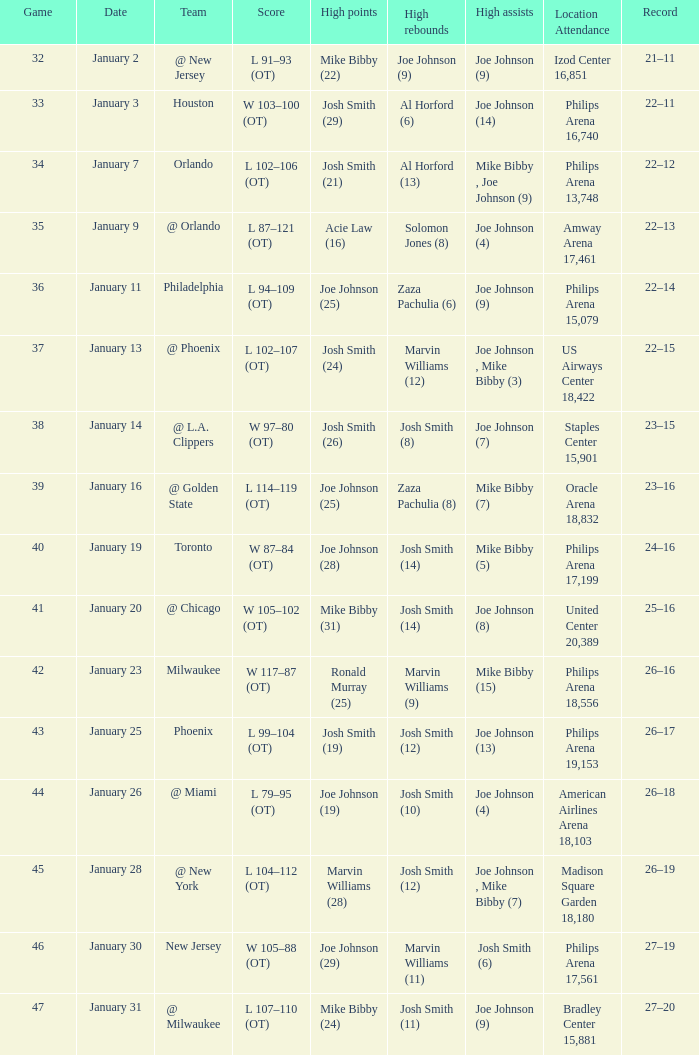What was the standing following the 37th game? 22–15. I'm looking to parse the entire table for insights. Could you assist me with that? {'header': ['Game', 'Date', 'Team', 'Score', 'High points', 'High rebounds', 'High assists', 'Location Attendance', 'Record'], 'rows': [['32', 'January 2', '@ New Jersey', 'L 91–93 (OT)', 'Mike Bibby (22)', 'Joe Johnson (9)', 'Joe Johnson (9)', 'Izod Center 16,851', '21–11'], ['33', 'January 3', 'Houston', 'W 103–100 (OT)', 'Josh Smith (29)', 'Al Horford (6)', 'Joe Johnson (14)', 'Philips Arena 16,740', '22–11'], ['34', 'January 7', 'Orlando', 'L 102–106 (OT)', 'Josh Smith (21)', 'Al Horford (13)', 'Mike Bibby , Joe Johnson (9)', 'Philips Arena 13,748', '22–12'], ['35', 'January 9', '@ Orlando', 'L 87–121 (OT)', 'Acie Law (16)', 'Solomon Jones (8)', 'Joe Johnson (4)', 'Amway Arena 17,461', '22–13'], ['36', 'January 11', 'Philadelphia', 'L 94–109 (OT)', 'Joe Johnson (25)', 'Zaza Pachulia (6)', 'Joe Johnson (9)', 'Philips Arena 15,079', '22–14'], ['37', 'January 13', '@ Phoenix', 'L 102–107 (OT)', 'Josh Smith (24)', 'Marvin Williams (12)', 'Joe Johnson , Mike Bibby (3)', 'US Airways Center 18,422', '22–15'], ['38', 'January 14', '@ L.A. Clippers', 'W 97–80 (OT)', 'Josh Smith (26)', 'Josh Smith (8)', 'Joe Johnson (7)', 'Staples Center 15,901', '23–15'], ['39', 'January 16', '@ Golden State', 'L 114–119 (OT)', 'Joe Johnson (25)', 'Zaza Pachulia (8)', 'Mike Bibby (7)', 'Oracle Arena 18,832', '23–16'], ['40', 'January 19', 'Toronto', 'W 87–84 (OT)', 'Joe Johnson (28)', 'Josh Smith (14)', 'Mike Bibby (5)', 'Philips Arena 17,199', '24–16'], ['41', 'January 20', '@ Chicago', 'W 105–102 (OT)', 'Mike Bibby (31)', 'Josh Smith (14)', 'Joe Johnson (8)', 'United Center 20,389', '25–16'], ['42', 'January 23', 'Milwaukee', 'W 117–87 (OT)', 'Ronald Murray (25)', 'Marvin Williams (9)', 'Mike Bibby (15)', 'Philips Arena 18,556', '26–16'], ['43', 'January 25', 'Phoenix', 'L 99–104 (OT)', 'Josh Smith (19)', 'Josh Smith (12)', 'Joe Johnson (13)', 'Philips Arena 19,153', '26–17'], ['44', 'January 26', '@ Miami', 'L 79–95 (OT)', 'Joe Johnson (19)', 'Josh Smith (10)', 'Joe Johnson (4)', 'American Airlines Arena 18,103', '26–18'], ['45', 'January 28', '@ New York', 'L 104–112 (OT)', 'Marvin Williams (28)', 'Josh Smith (12)', 'Joe Johnson , Mike Bibby (7)', 'Madison Square Garden 18,180', '26–19'], ['46', 'January 30', 'New Jersey', 'W 105–88 (OT)', 'Joe Johnson (29)', 'Marvin Williams (11)', 'Josh Smith (6)', 'Philips Arena 17,561', '27–19'], ['47', 'January 31', '@ Milwaukee', 'L 107–110 (OT)', 'Mike Bibby (24)', 'Josh Smith (11)', 'Joe Johnson (9)', 'Bradley Center 15,881', '27–20']]} 